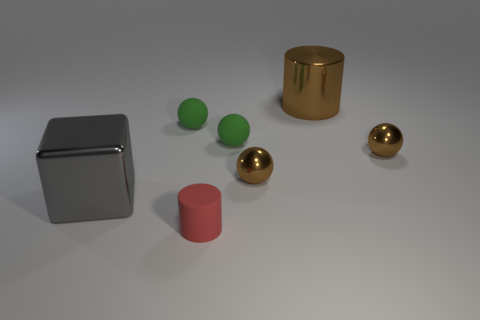The big metallic object that is behind the small green object that is right of the thing in front of the shiny block is what shape?
Give a very brief answer. Cylinder. There is a small object that is in front of the gray block; is its shape the same as the green rubber object that is to the left of the small red thing?
Keep it short and to the point. No. What number of other objects are there of the same material as the cube?
Provide a short and direct response. 3. What shape is the big gray object that is made of the same material as the big brown thing?
Give a very brief answer. Cube. Does the metal cylinder have the same size as the gray metallic object?
Your response must be concise. Yes. There is a matte cylinder in front of the small green ball that is to the right of the small red thing; how big is it?
Your answer should be compact. Small. What number of balls are either tiny brown objects or green matte objects?
Keep it short and to the point. 4. Does the gray block have the same size as the rubber thing that is in front of the gray metallic thing?
Ensure brevity in your answer.  No. Are there more large gray things that are to the left of the block than small brown spheres?
Provide a short and direct response. No. There is a cylinder that is made of the same material as the big gray object; what is its size?
Provide a short and direct response. Large. 